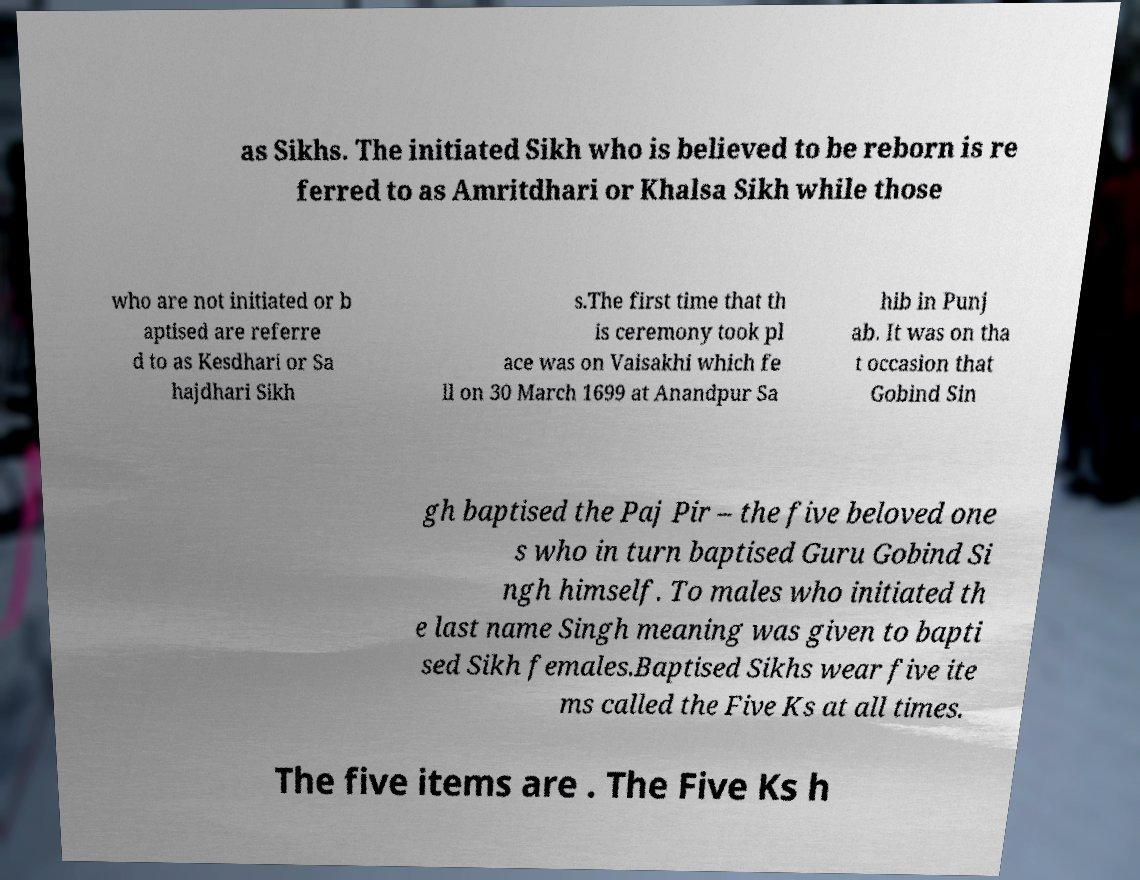Please identify and transcribe the text found in this image. as Sikhs. The initiated Sikh who is believed to be reborn is re ferred to as Amritdhari or Khalsa Sikh while those who are not initiated or b aptised are referre d to as Kesdhari or Sa hajdhari Sikh s.The first time that th is ceremony took pl ace was on Vaisakhi which fe ll on 30 March 1699 at Anandpur Sa hib in Punj ab. It was on tha t occasion that Gobind Sin gh baptised the Paj Pir – the five beloved one s who in turn baptised Guru Gobind Si ngh himself. To males who initiated th e last name Singh meaning was given to bapti sed Sikh females.Baptised Sikhs wear five ite ms called the Five Ks at all times. The five items are . The Five Ks h 